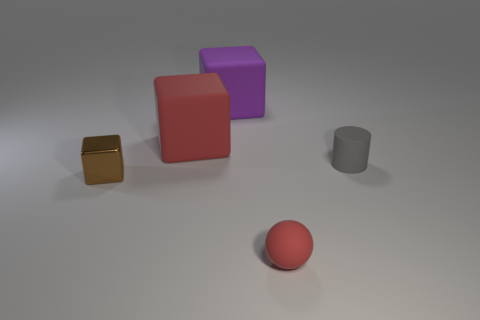Are there any objects that stand out due to their color? Yes, the red sphere stands out due to its vibrant color, which contrasts with the more subdued hues of the other objects and the neutral grey background. What does its color contrast suggest about its significance? In visual composition, a contrasting color can draw attention to an object, suggesting it may be of particular importance or a focal point within the scene. 